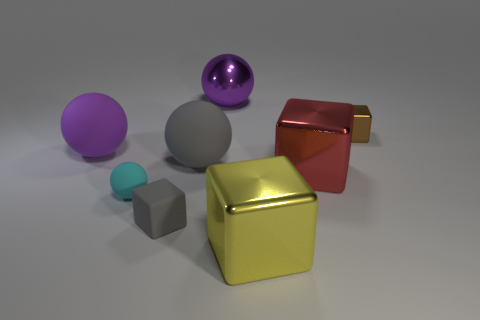Is the number of metal cubes on the left side of the metallic ball greater than the number of gray things that are behind the cyan thing?
Give a very brief answer. No. There is a small metal object that is the same shape as the small gray matte thing; what color is it?
Ensure brevity in your answer.  Brown. Do the large matte sphere right of the large purple rubber sphere and the small rubber ball have the same color?
Provide a short and direct response. No. How many small brown spheres are there?
Offer a terse response. 0. Is the material of the large block behind the gray cube the same as the cyan sphere?
Your answer should be compact. No. Are there any other things that have the same material as the gray sphere?
Your answer should be very brief. Yes. How many metal things are in front of the big purple object left of the block that is to the left of the purple metallic object?
Offer a very short reply. 2. The yellow block has what size?
Your response must be concise. Large. Is the color of the tiny metallic cube the same as the tiny ball?
Keep it short and to the point. No. There is a purple object right of the gray rubber sphere; what size is it?
Your answer should be compact. Large. 